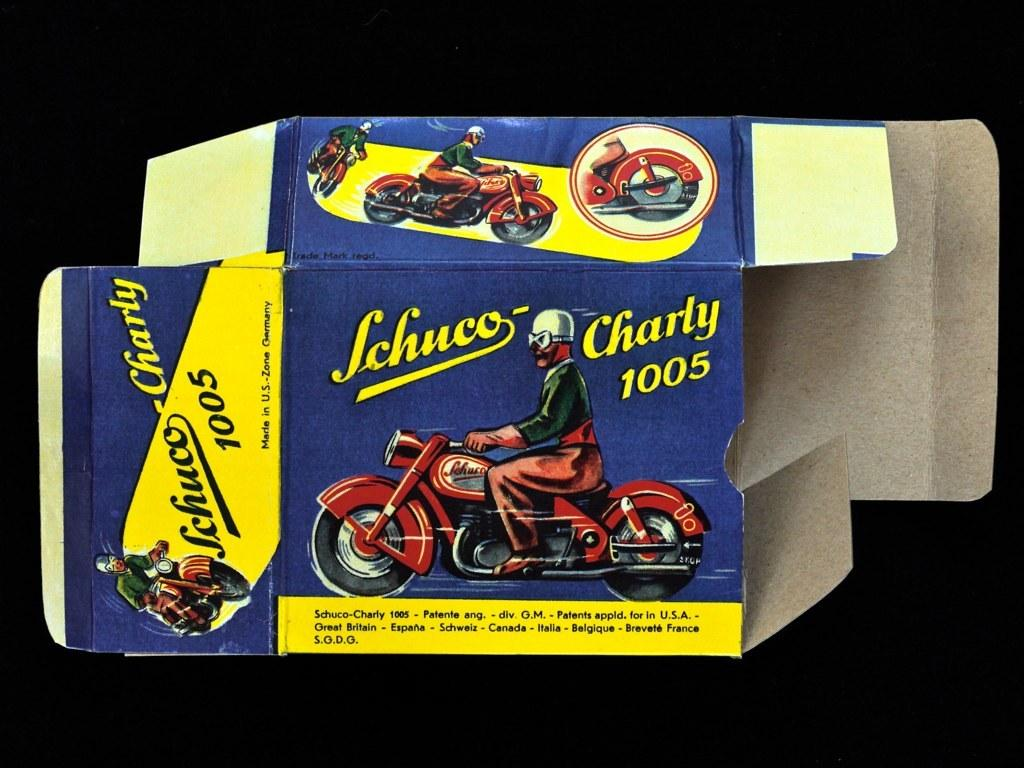What object is present in the image that is not a person or motorcycle? There is a box in the image. What are the people in the image doing? The people are on motorcycles in the image. What is written or printed on the box? There is text on the box. How would you describe the overall lighting in the image? The background of the image is dark. What type of leather is being used to make the guitar in the image? There is no guitar present in the image; it only features a box and people on motorcycles. How does the van in the image contribute to the overall composition of the image? There is no van present in the image. 